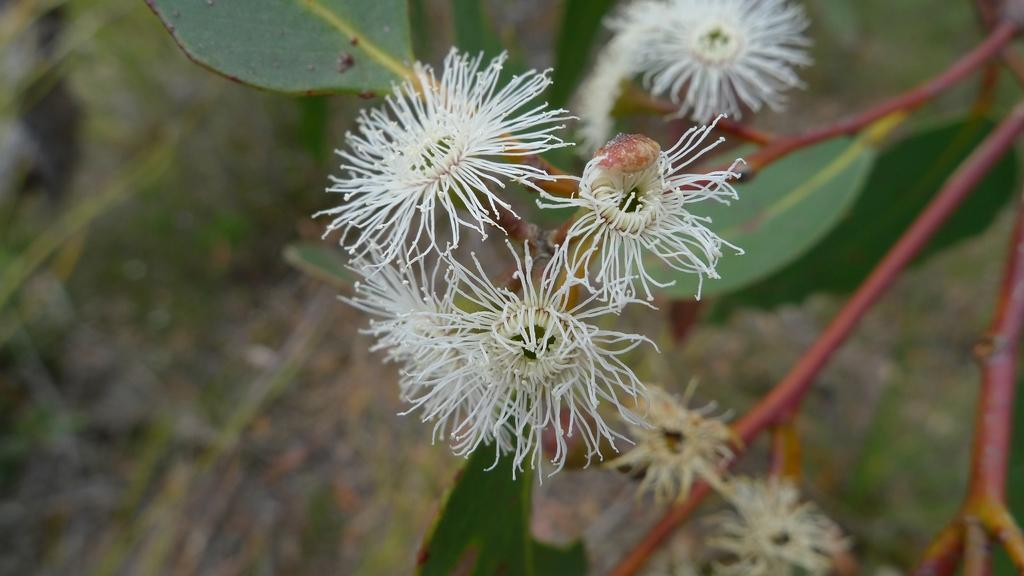What type of plants can be seen in the image? There are flowers and leaves in the image. Can you describe the appearance of the flowers? Unfortunately, the facts provided do not give enough detail to describe the appearance of the flowers. What is the context of the image? The facts provided only mention the presence of flowers and leaves, so it is not possible to determine the context of the image. What type of popcorn is being served in the image? There is no popcorn present in the image; it only features flowers and leaves. What is the most intricate detail on the cast in the image? There is no cast present in the image, as it only contains flowers and leaves. 